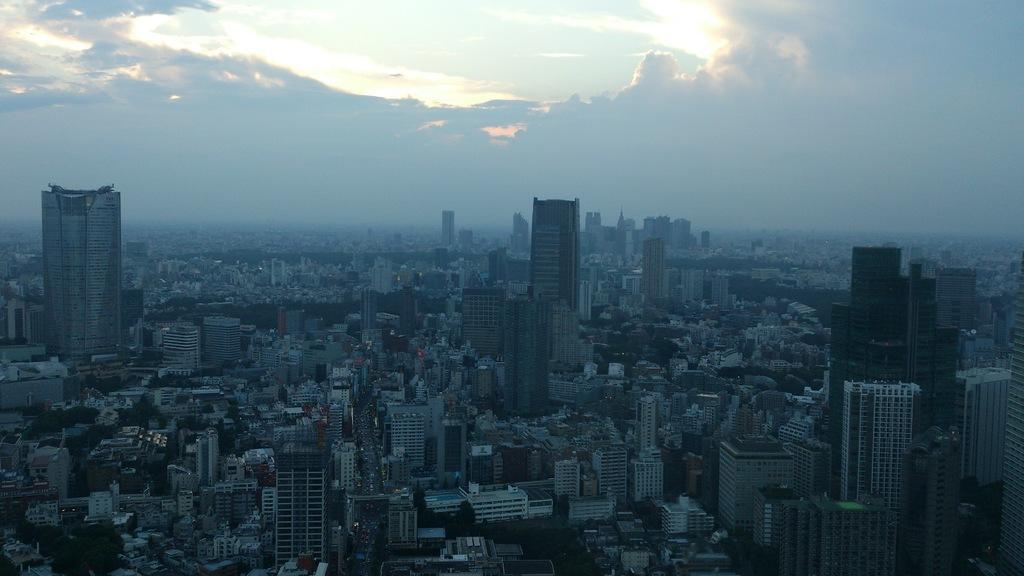What structures are visible in the image? There are multiple buildings in the image. What part of the natural environment is visible in the image? The sky is visible in the image. How would you describe the sky's condition in the image? The sky appears to be cloudy in the image. Can you see a bear walking down the street in the image? There is no bear or street present in the image; it features multiple buildings and a cloudy sky. 